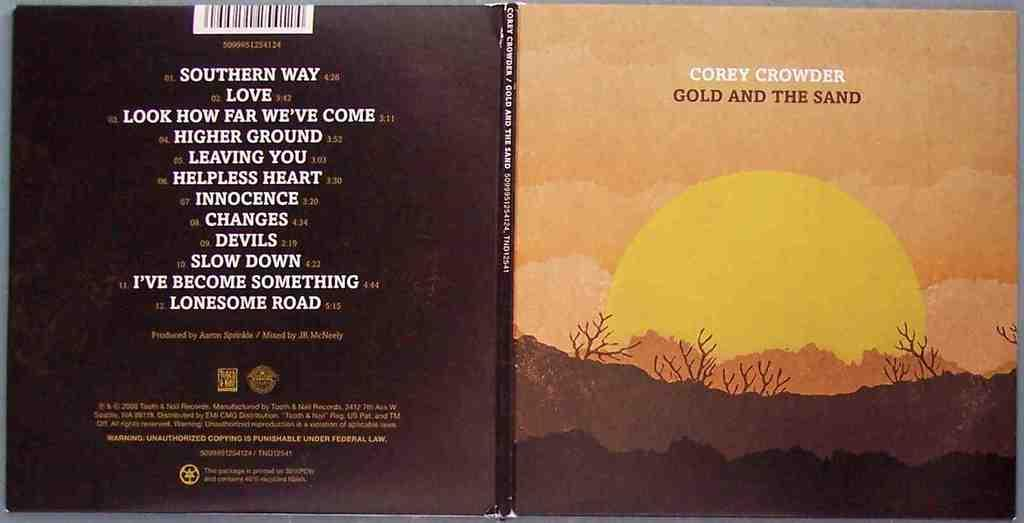<image>
Share a concise interpretation of the image provided. A cd cover for music by Corey Crowder shows a sunset and song list. 